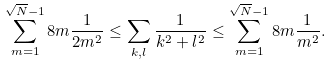<formula> <loc_0><loc_0><loc_500><loc_500>\sum _ { m = 1 } ^ { \sqrt { N } - 1 } 8 m \frac { 1 } { 2 m ^ { 2 } } \leq \sum _ { k , l } \frac { 1 } { k ^ { 2 } + l ^ { 2 } } \leq \sum _ { m = 1 } ^ { \sqrt { N } - 1 } 8 m \frac { 1 } { m ^ { 2 } } .</formula> 